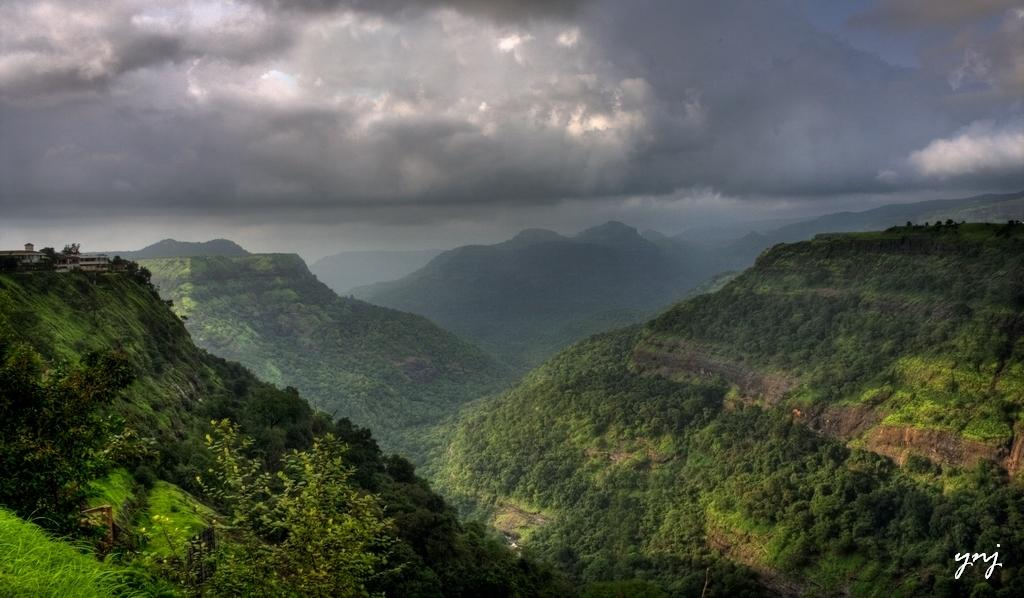What type of landscape feature can be seen in the image? There are hills in the image. What type of vegetation is present in the image? There are trees in the image. What is visible at the top of the image? The sky is visible at the top of the image. What can be observed in the sky? Clouds are present in the sky. How much payment is required to enter the image? There is no payment required to enter the image, as it is a photograph or illustration and not a physical location. 